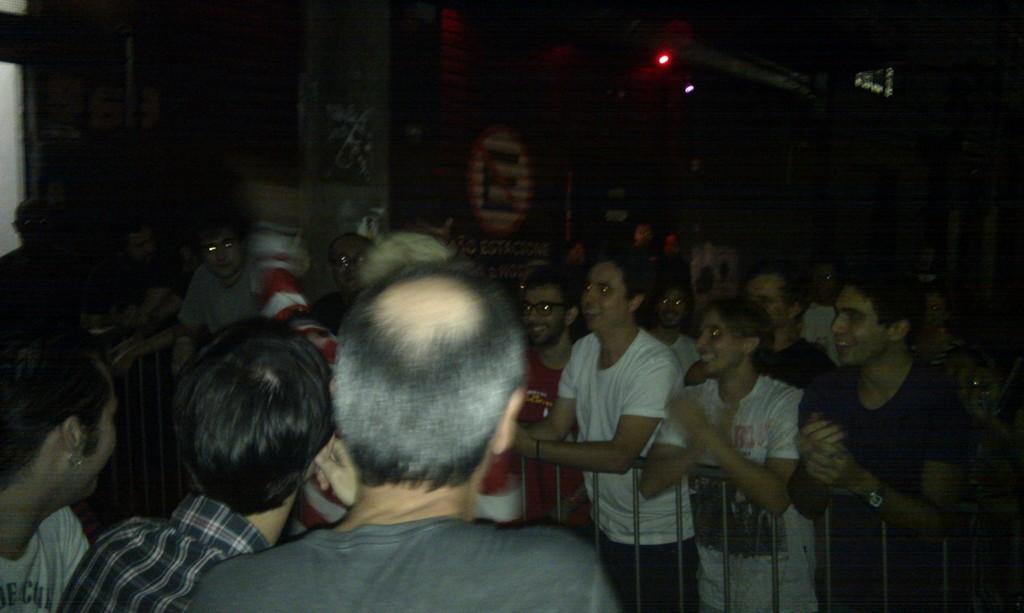Can you describe this image briefly? In this picture I can see group of people are standing among them some are standing behind a fence. In the background I can see some lights. The background of the image is dark. 